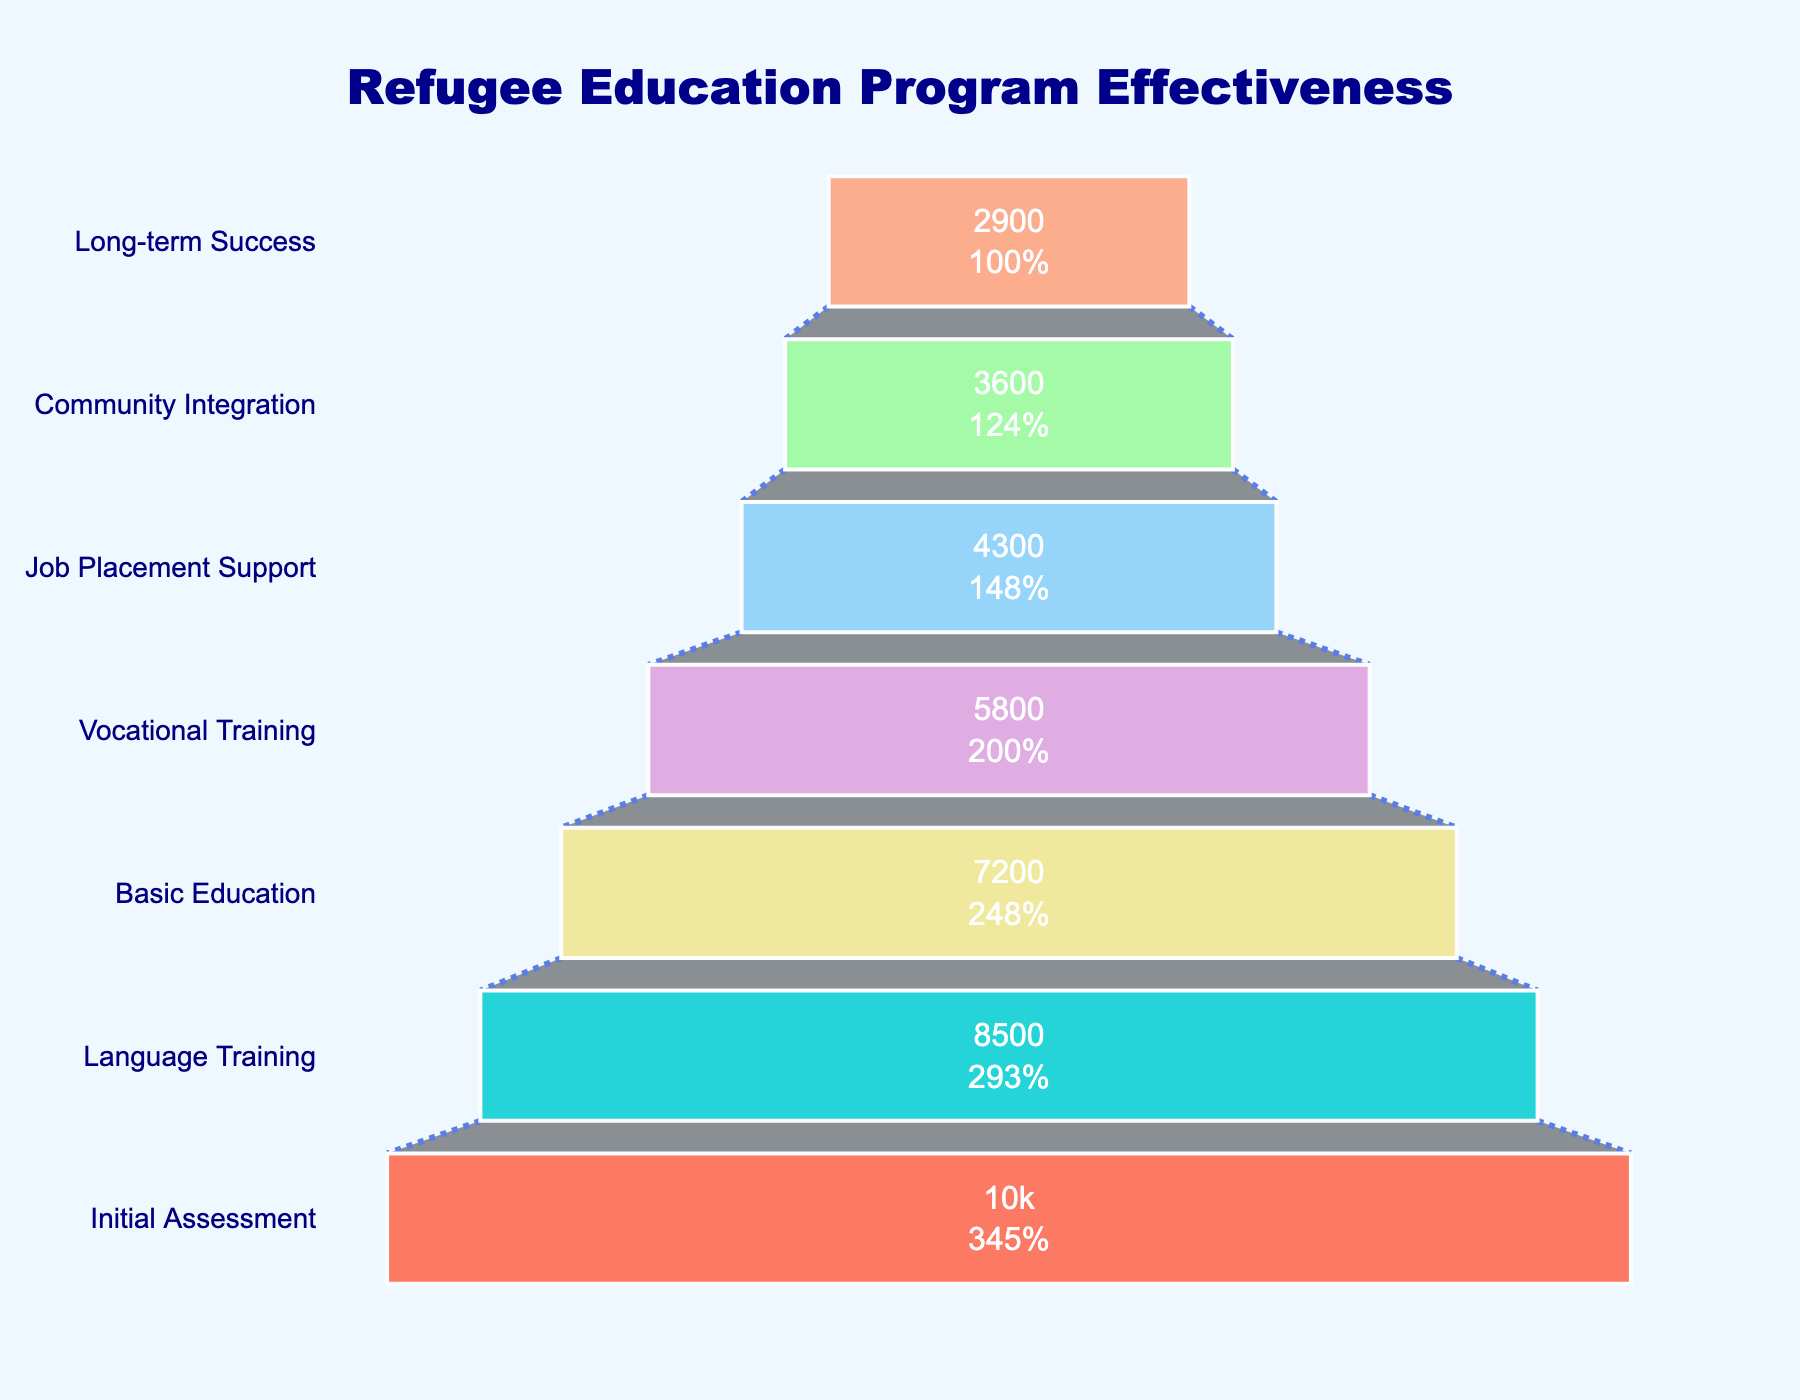What is the title of the figure? The title can be found at the top of the figure.
Answer: Refugee Education Program Effectiveness How many refugees move on from the Initial Assessment to Language Training? The number in the Language Training stage directly follows the Initial Assessment stage on the funnel.
Answer: 8,500 What percentage of refugees reach the Basic Education stage from the Initial Assessment stage? The funnel chart has percentages included. Look for the percentage value for the Basic Education stage relative to the Initial Assessment stage.
Answer: 72% How many stages are present in the figure? Count the total distinct stages labeled on the funnel chart.
Answer: 7 How many refugees are successfully integrated into the community from the Initial Assessment stage? Follow the funnel stages to the Community Integration stage.
Answer: 3,600 What is the highest percentage drop from one stage to the next? Calculate the percentage drops for each transition between stages and find the maximum. Explanation in detail: From Language Training to Basic Education, the percentage drop is (8,500 - 7,200) / 8,500 x 100 ≈ 15.29% From Basic Education to Vocational Training, it is (7,200 - 5,800) / 7,200 x 100 ≈ 19.44% From Vocational Training to Job Placement Support, it is (5,800 - 4,300) / 5,800 x 100 ≈ 25.86% From Job Placement Support to Community Integration, it is (4,300 - 3,600) / 4,300 x 100 ≈ 16.28% From Community Integration to Long-term Success, it is (3,600 - 2,900) / 3,600 x 100 ≈ 19.44% The highest drop is thus from Vocational Training to Job Placement Support, with approximately 25.86%
Answer: Vocational Training to Job Placement Support, 25.86% What stage is directly before Long-term Success? The funnel chart shows the order of stages. Identify the stage just before Long-term Success.
Answer: Community Integration How many refugees progress from Vocational Training to Community Integration? Follow the funnel from the Vocational Training stage down to the Community Integration stage.
Answer: 3,600 